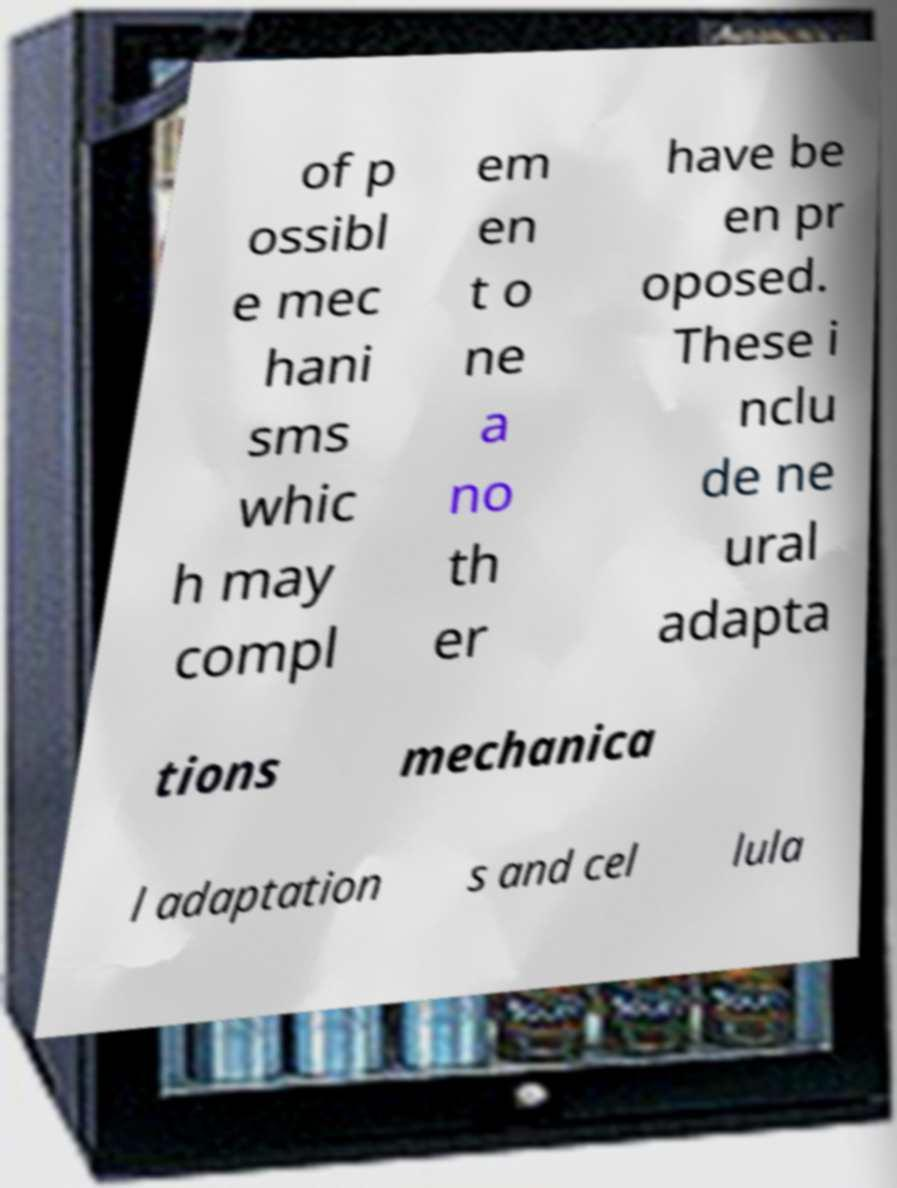Can you accurately transcribe the text from the provided image for me? of p ossibl e mec hani sms whic h may compl em en t o ne a no th er have be en pr oposed. These i nclu de ne ural adapta tions mechanica l adaptation s and cel lula 